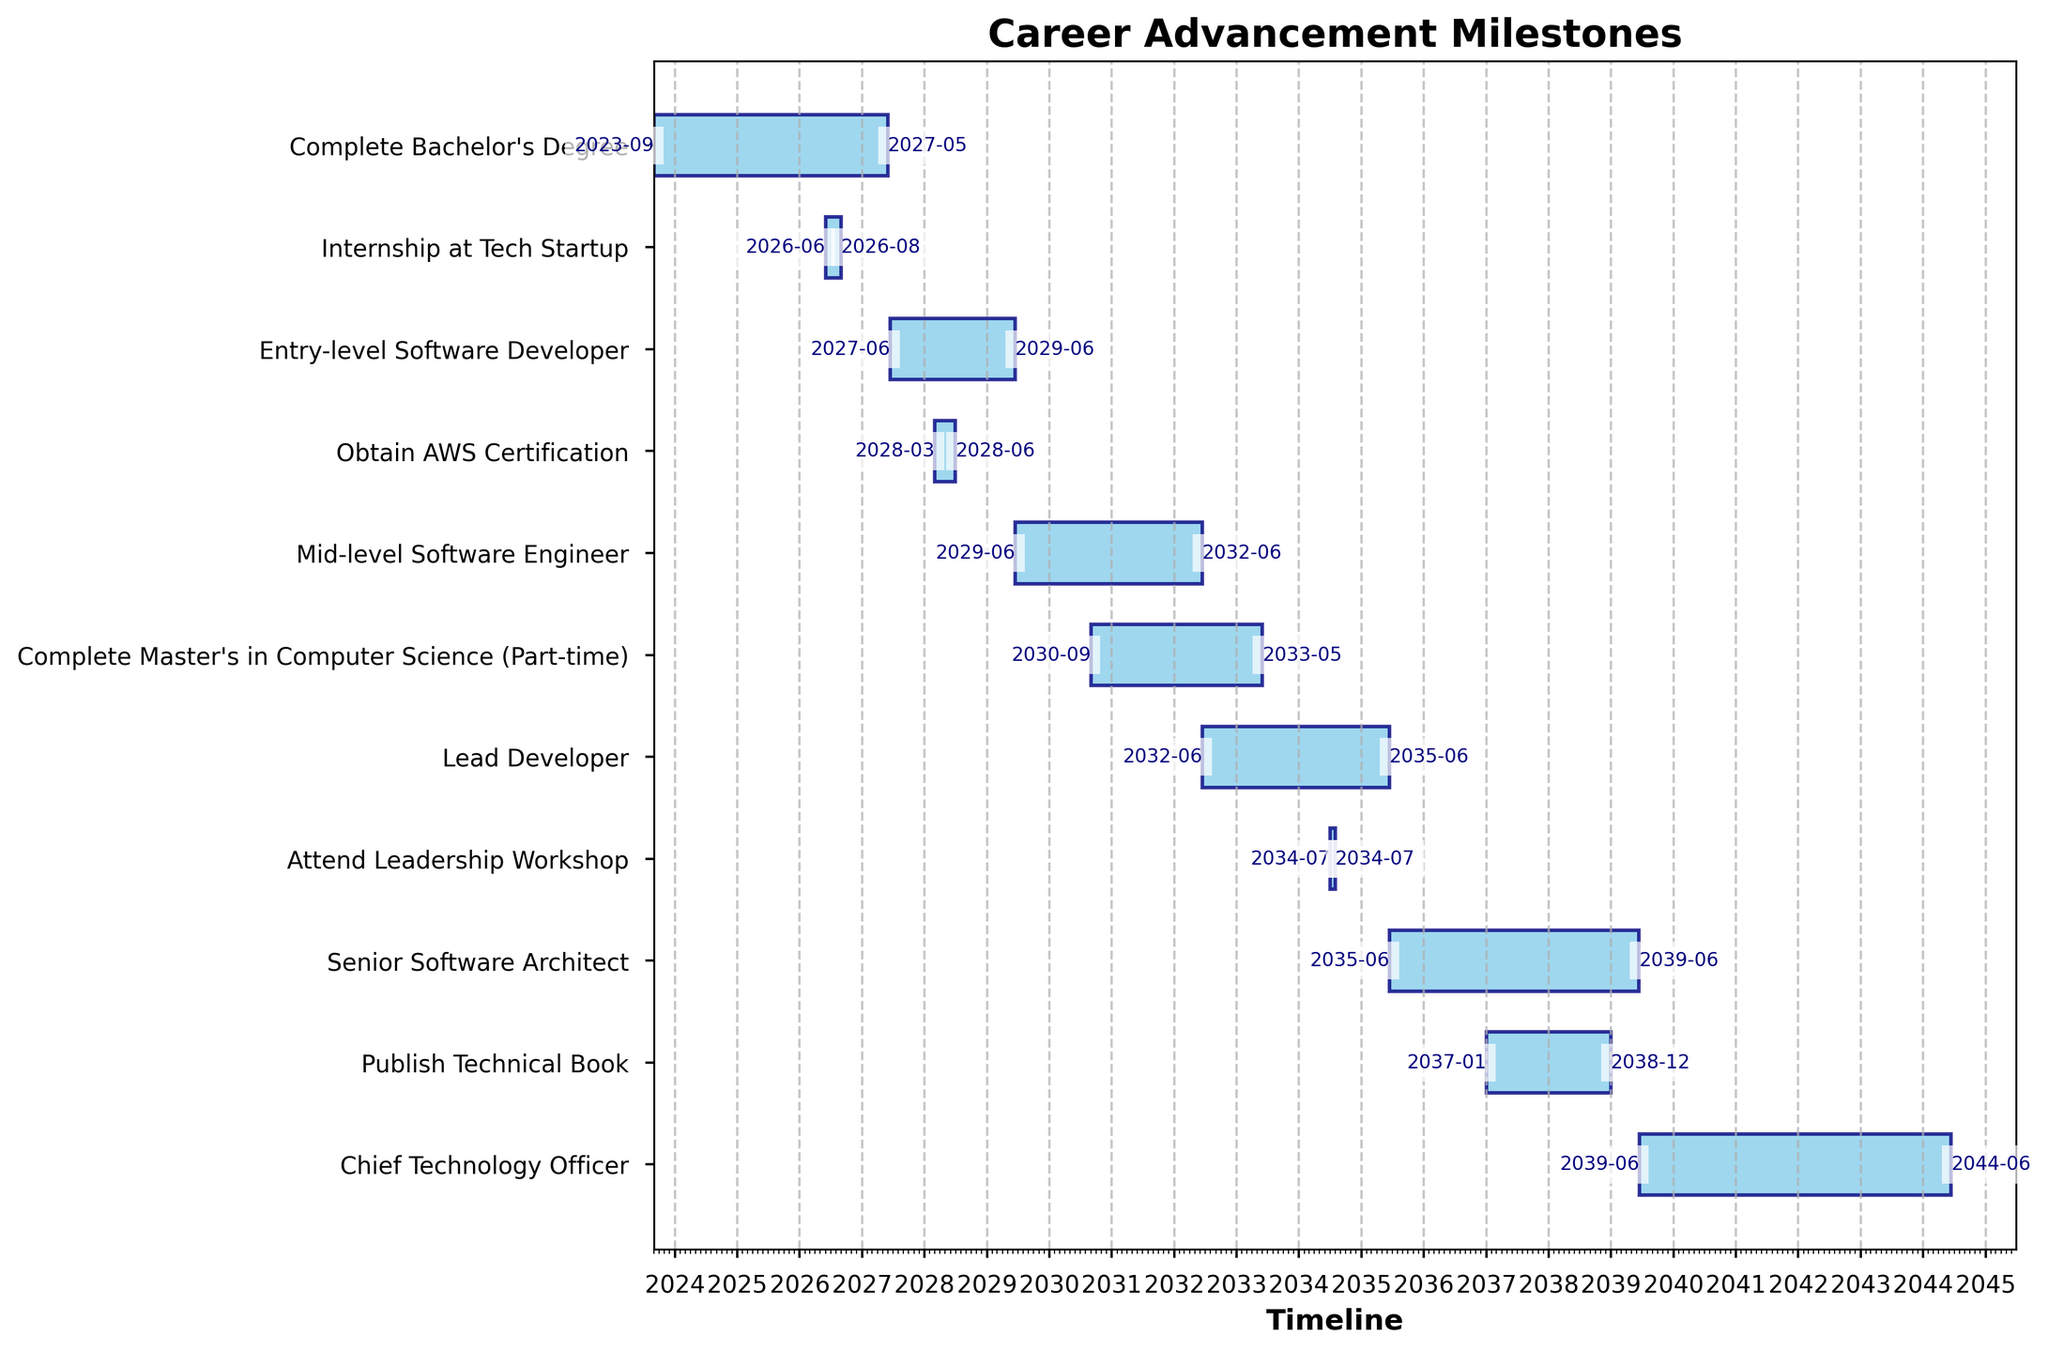What's the title of the figure? The title of the figure is displayed at the top of the chart. It is meant to give a clear and concise summary of what the chart represents.
Answer: Career Advancement Milestones What is the time span depicted in the chart? To find the time span, observe the x-axis labels marking the timeline. The timeline starts from the earliest date and ends at the latest date in the chart.
Answer: 2023 to 2044 Which task appears to have the shortest duration? By comparing the lengths of the horizontal bars representing the tasks, the task with the shortest bar duration is identified.
Answer: Attend Leadership Workshop When does the "Mid-level Software Engineer" task start and end? Look at the starting and ending points of the "Mid-level Software Engineer" task on the y-axis, noting the corresponding dates on the x-axis. The dates are usually displayed on the bar itself.
Answer: Start: 2029-06-15, End: 2032-06-14 How many tasks span more than 3 years? Determine each task’s duration by calculating the difference between its start and end dates. Count the tasks where this duration exceeds 3 years.
Answer: 6 Which milestone starts immediately after completing the Bachelor's Degree? Identify when the Bachelor's Degree completion ends, then check which task starts next on the timeline. The juxtaposition of tasks on the chart helps identify this.
Answer: Internship at Tech Startup How long is the duration of the "Complete Master's in Computer Science (Part-time)" task? Calculate the time between the start and end dates of the "Complete Master's in Computer Science (Part-time)" task.
Answer: Approximately 2 years and 9 months Which task ends in 2038? Look for the tasks ending in 2038 by examining the end points of the horizontal bars and cross-referencing with the labels on the y-axis.
Answer: Publish Technical Book Which comes first: "Obtain AWS Certification" or "Entry-level Software Developer"? Compare the start dates of these two tasks by looking at their positions on the timeline. Whichever starts earlier is the one that comes first.
Answer: Entry-level Software Developer How many tasks involve some form of education or certification? Count the tasks that explicitly mention degrees, certifications, or formal education workshops.
Answer: 3 